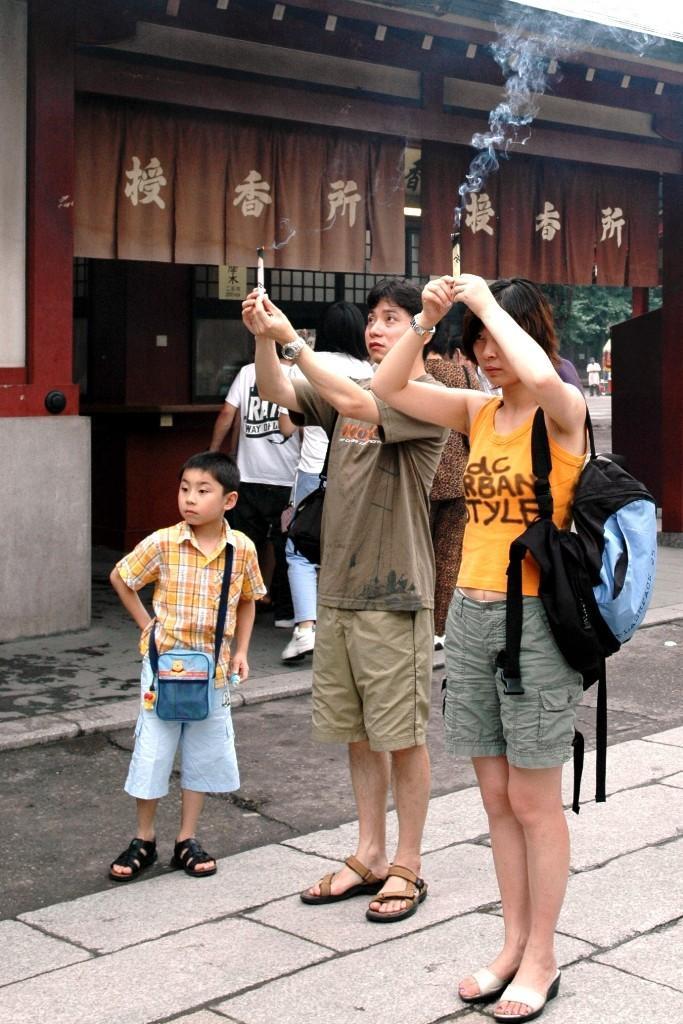How would you summarize this image in a sentence or two? In this image, there are two persons wearing clothes and holding incense sticks with their hands. There is kid on the left side of the image standing in front of the building. 